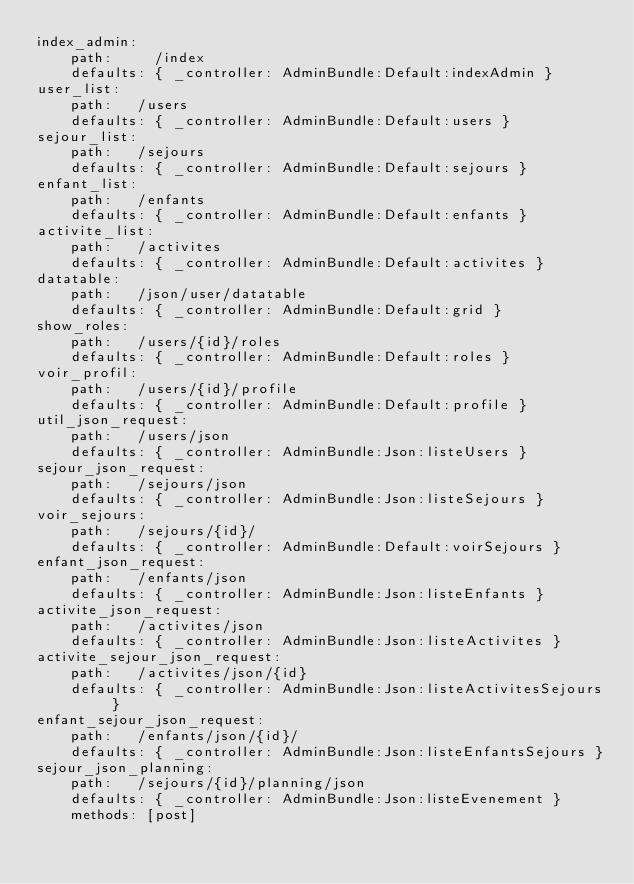<code> <loc_0><loc_0><loc_500><loc_500><_YAML_>index_admin:
    path:     /index
    defaults: { _controller: AdminBundle:Default:indexAdmin }
user_list:
    path:   /users
    defaults: { _controller: AdminBundle:Default:users }
sejour_list:
    path:   /sejours
    defaults: { _controller: AdminBundle:Default:sejours }
enfant_list:
    path:   /enfants
    defaults: { _controller: AdminBundle:Default:enfants }
activite_list:
    path:   /activites
    defaults: { _controller: AdminBundle:Default:activites }
datatable:
    path:   /json/user/datatable
    defaults: { _controller: AdminBundle:Default:grid }
show_roles:
    path:   /users/{id}/roles
    defaults: { _controller: AdminBundle:Default:roles }
voir_profil:
    path:   /users/{id}/profile
    defaults: { _controller: AdminBundle:Default:profile }
util_json_request:
    path:   /users/json
    defaults: { _controller: AdminBundle:Json:listeUsers }
sejour_json_request:
    path:   /sejours/json
    defaults: { _controller: AdminBundle:Json:listeSejours }
voir_sejours:
    path:   /sejours/{id}/
    defaults: { _controller: AdminBundle:Default:voirSejours }
enfant_json_request:
    path:   /enfants/json
    defaults: { _controller: AdminBundle:Json:listeEnfants }
activite_json_request:
    path:   /activites/json
    defaults: { _controller: AdminBundle:Json:listeActivites }
activite_sejour_json_request:
    path:   /activites/json/{id}
    defaults: { _controller: AdminBundle:Json:listeActivitesSejours }
enfant_sejour_json_request:
    path:   /enfants/json/{id}/
    defaults: { _controller: AdminBundle:Json:listeEnfantsSejours }
sejour_json_planning:
    path:   /sejours/{id}/planning/json
    defaults: { _controller: AdminBundle:Json:listeEvenement }
    methods: [post]</code> 